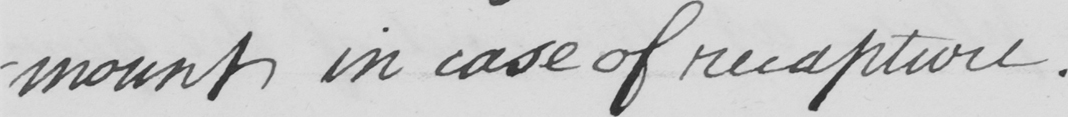What is written in this line of handwriting? -mount in case of recapture . 